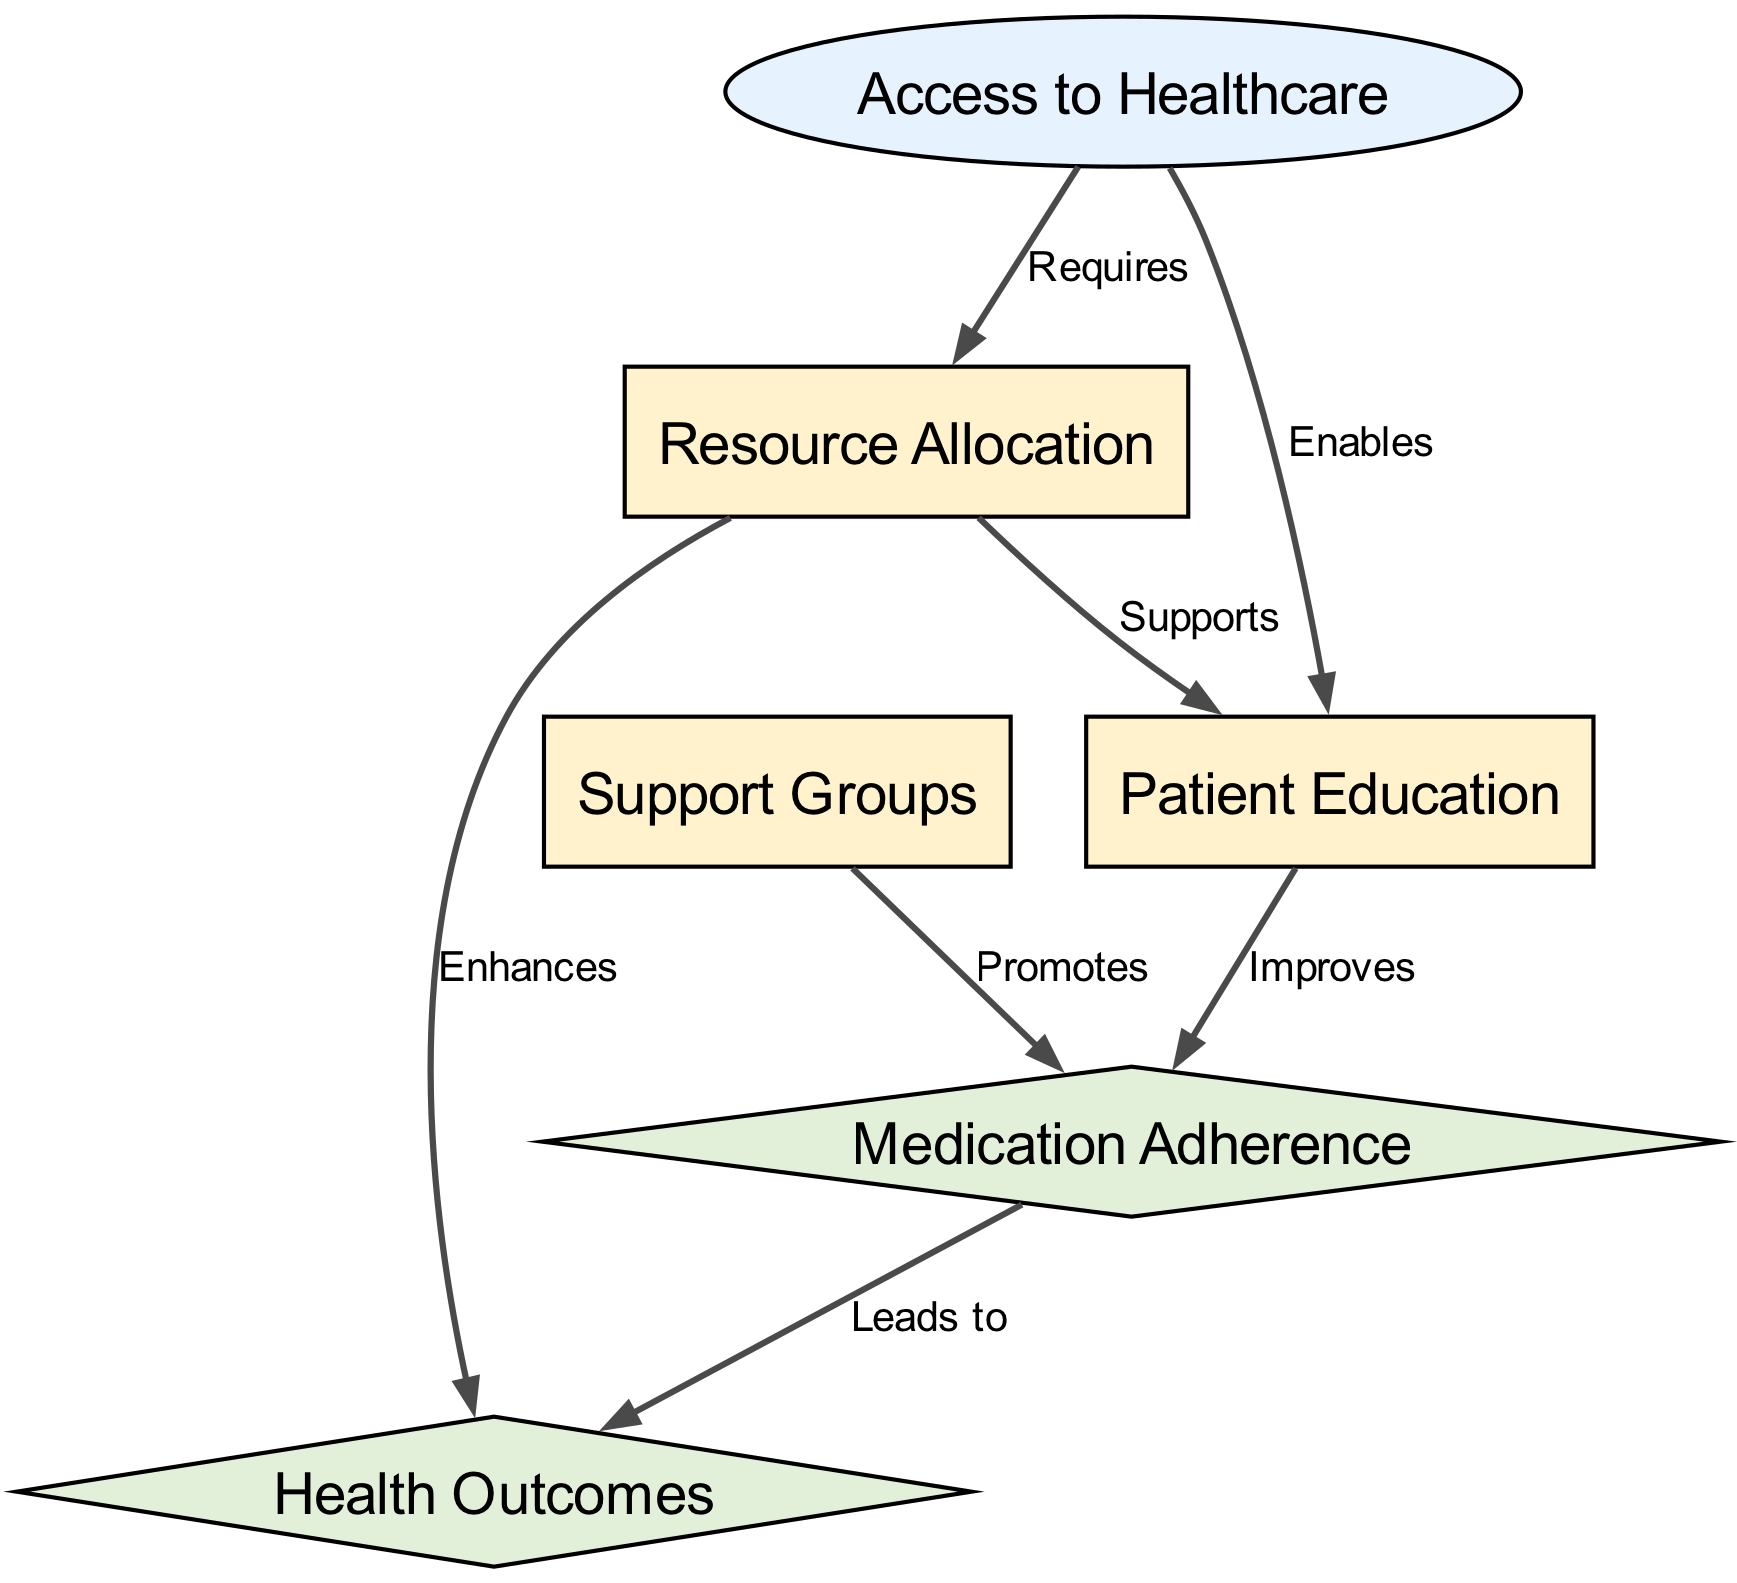What is the total number of nodes in the diagram? The total number of nodes can be calculated by counting all the nodes listed in the "nodes" array of the data. There are six nodes labeled "Access to Healthcare," "Patient Education," "Support Groups," "Medication Adherence," "Resource Allocation," and "Health Outcomes."
Answer: 6 What type of node is "Access to Healthcare"? By checking the node type attribute in the "nodes" array, we see that "Access to Healthcare" is labeled as an "input" type node.
Answer: input Which node directly enhances "Health Outcomes"? To find which node enhances "Health Outcomes," we look at the edges in the "edges" array. The edge from "Resource Allocation" to "Health Outcomes" is labeled "Enhances," indicating that "Resource Allocation" directly enhances "Health Outcomes."
Answer: Resource Allocation How many edges originate from "Resource Allocation"? We can determine the number of edges by examining the "edges" array for any edge where "Resource Allocation" is listed as the originating node. There are two edges originating from "Resource Allocation."
Answer: 2 What is the relationship between "Patient Education" and "Medication Adherence"? We analyze the connections in the diagram. The edge from "Patient Education" to "Medication Adherence" is labeled "Improves," indicating that "Patient Education" improves "Medication Adherence."
Answer: Improves Which two nodes promote "Medication Adherence"? By reviewing the edges, we find that both "Patient Education" and "Support Groups" have edges leading to "Medication Adherence." Therefore, these two nodes promote "Medication Adherence."
Answer: Patient Education, Support Groups What is the final output derived from "Medication Adherence"? Based on the flow of the diagram, the edge from "Medication Adherence" to "Health Outcomes" is labeled "Leads to," which shows that "Medication Adherence" leads to the final output of "Health Outcomes."
Answer: Health Outcomes How does "Access to Healthcare" influence "Resource Allocation"? The diagram includes an edge from "Access to Healthcare" to "Resource Allocation," labeled "Requires," indicating that access to healthcare is a requirement influencing the allocation of resources.
Answer: Requires What effect does "Support Groups" have on "Medication Adherence"? According to the edges, "Support Groups" have an edge leading to "Medication Adherence," which is labeled "Promotes," indicating that the presence of support groups has a positive effect on medication adherence.
Answer: Promotes 